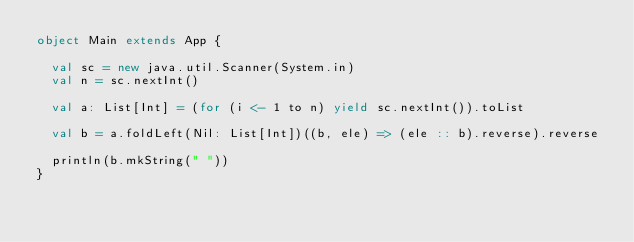Convert code to text. <code><loc_0><loc_0><loc_500><loc_500><_Scala_>object Main extends App {

  val sc = new java.util.Scanner(System.in)
  val n = sc.nextInt()

  val a: List[Int] = (for (i <- 1 to n) yield sc.nextInt()).toList

  val b = a.foldLeft(Nil: List[Int])((b, ele) => (ele :: b).reverse).reverse

  println(b.mkString(" "))
}</code> 